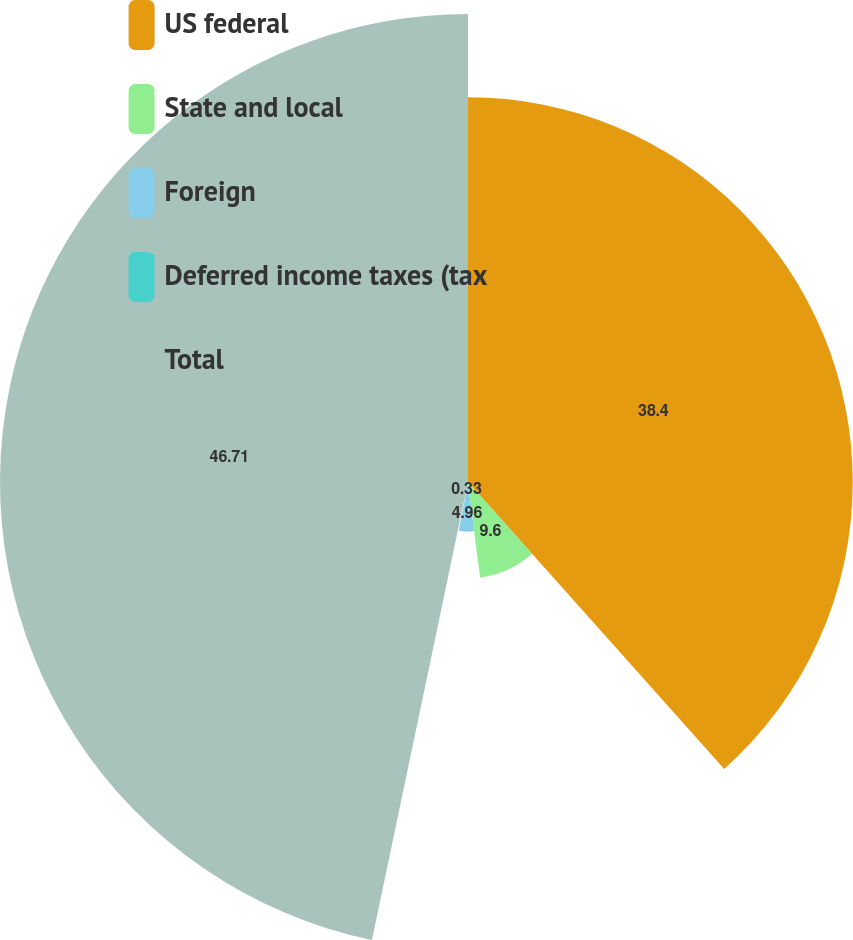Convert chart. <chart><loc_0><loc_0><loc_500><loc_500><pie_chart><fcel>US federal<fcel>State and local<fcel>Foreign<fcel>Deferred income taxes (tax<fcel>Total<nl><fcel>38.4%<fcel>9.6%<fcel>4.96%<fcel>0.33%<fcel>46.71%<nl></chart> 